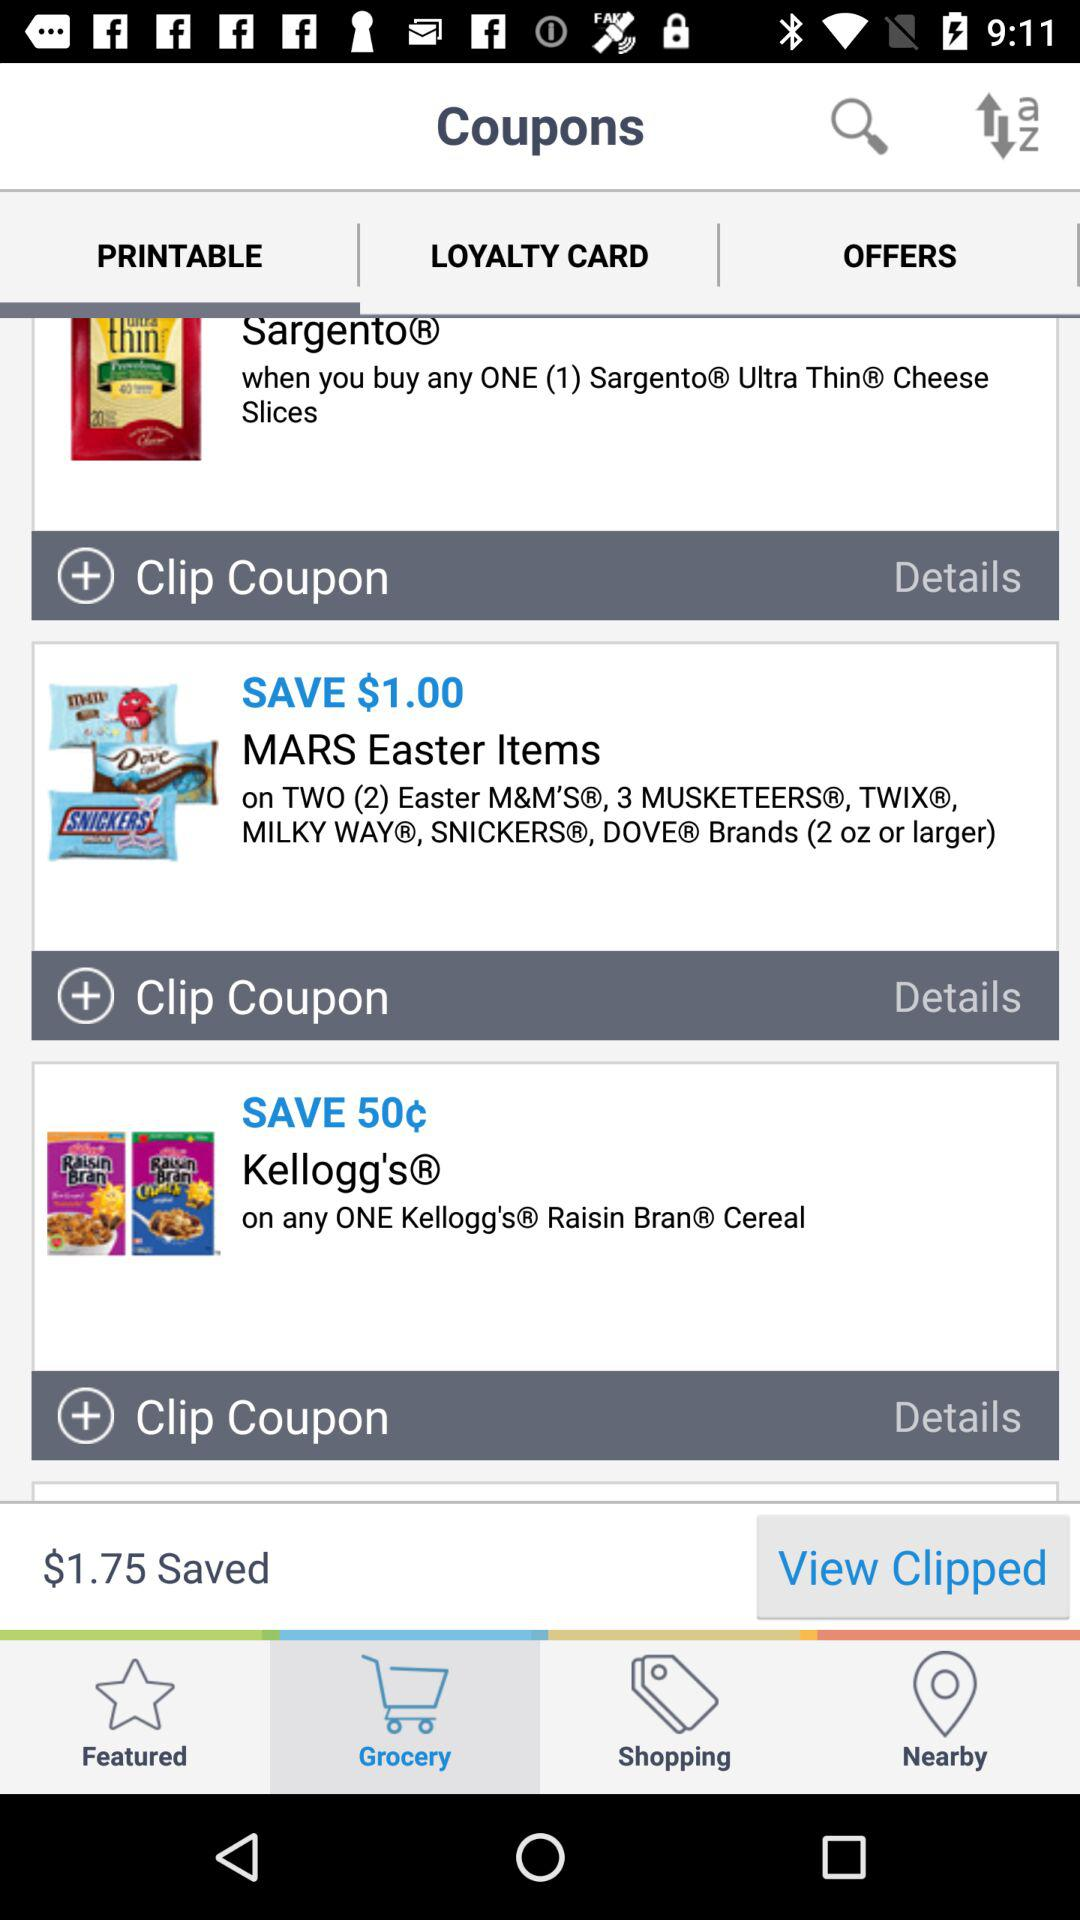How much money can I save if I clip all of these coupons?
Answer the question using a single word or phrase. $1.75 